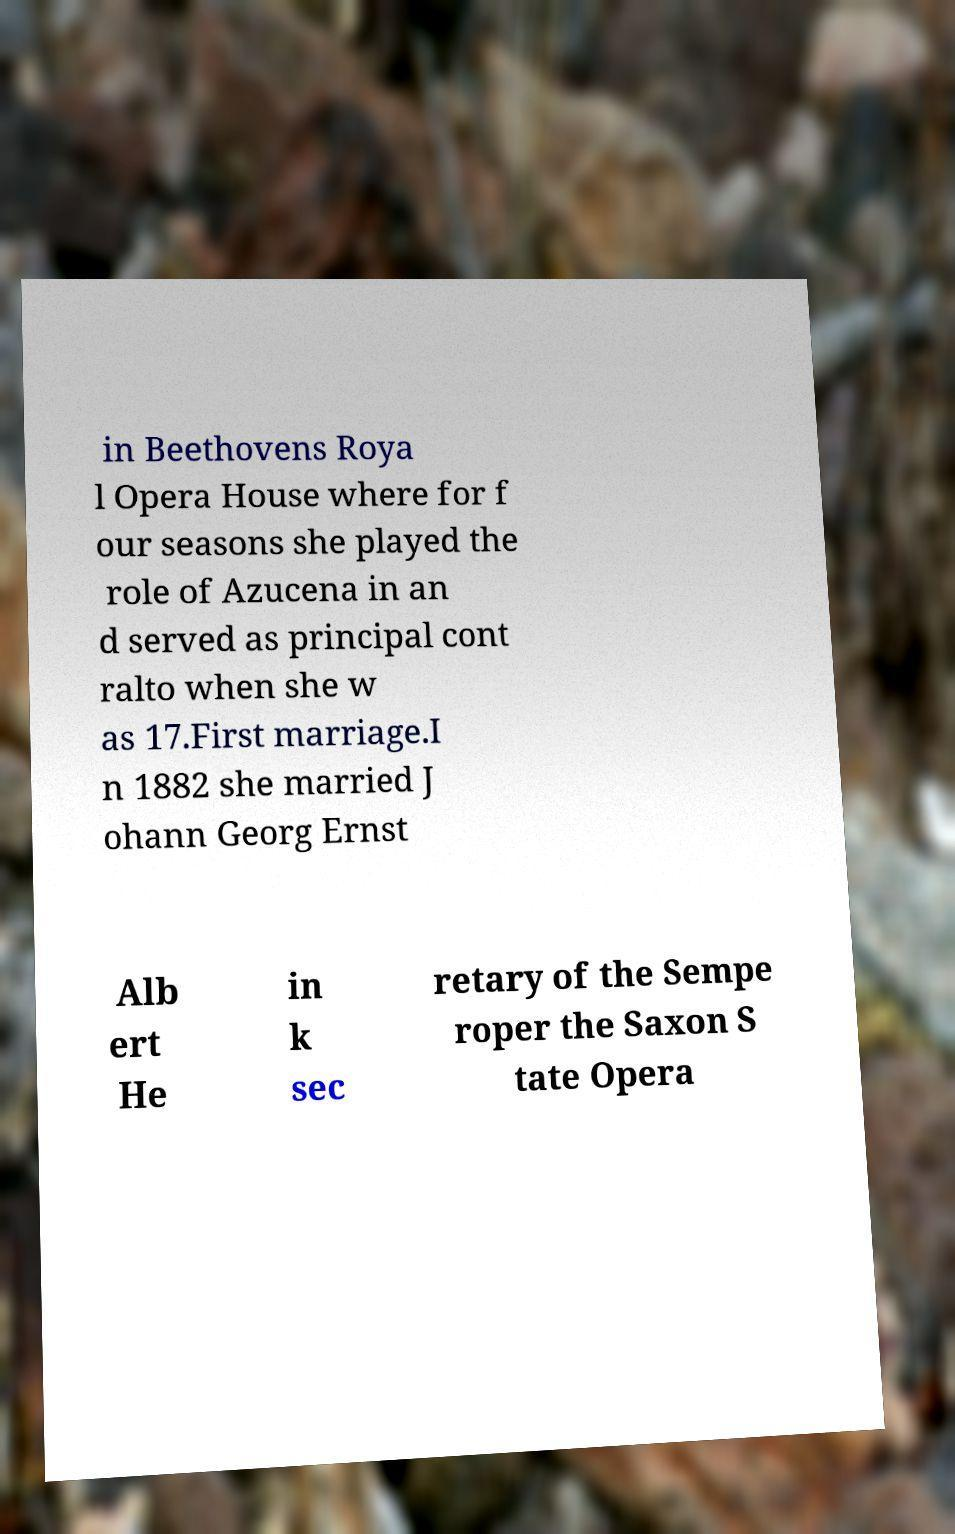Could you extract and type out the text from this image? in Beethovens Roya l Opera House where for f our seasons she played the role of Azucena in an d served as principal cont ralto when she w as 17.First marriage.I n 1882 she married J ohann Georg Ernst Alb ert He in k sec retary of the Sempe roper the Saxon S tate Opera 